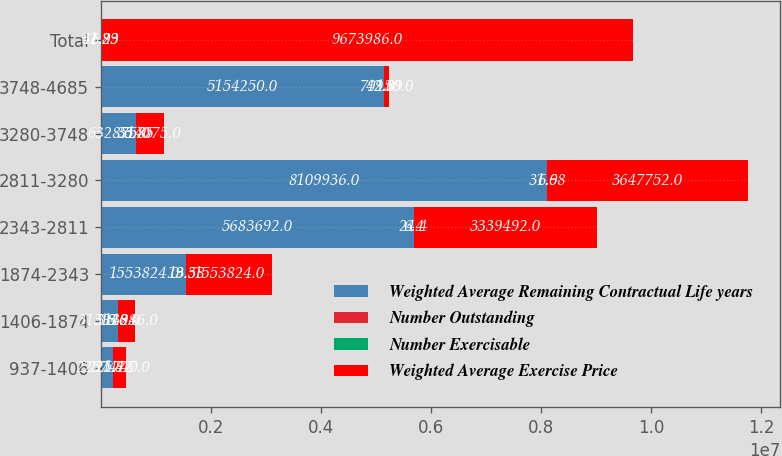<chart> <loc_0><loc_0><loc_500><loc_500><stacked_bar_chart><ecel><fcel>937-1406<fcel>1406-1874<fcel>1874-2343<fcel>2343-2811<fcel>2811-3280<fcel>3280-3748<fcel>3748-4685<fcel>Total<nl><fcel>Weighted Average Remaining Contractual Life years<fcel>225747<fcel>313946<fcel>1.55382e+06<fcel>5.68369e+06<fcel>8.10994e+06<fcel>632875<fcel>5.15425e+06<fcel>42.89<nl><fcel>Number Outstanding<fcel>1.4<fcel>3.8<fcel>3.3<fcel>6.4<fcel>6.9<fcel>5.7<fcel>9<fcel>6.9<nl><fcel>Number Exercisable<fcel>11.82<fcel>18.28<fcel>19.58<fcel>24.4<fcel>31.68<fcel>33.85<fcel>42.89<fcel>31.23<nl><fcel>Weighted Average Exercise Price<fcel>225747<fcel>313946<fcel>1.55382e+06<fcel>3.33949e+06<fcel>3.64775e+06<fcel>514075<fcel>79150<fcel>9.67399e+06<nl></chart> 